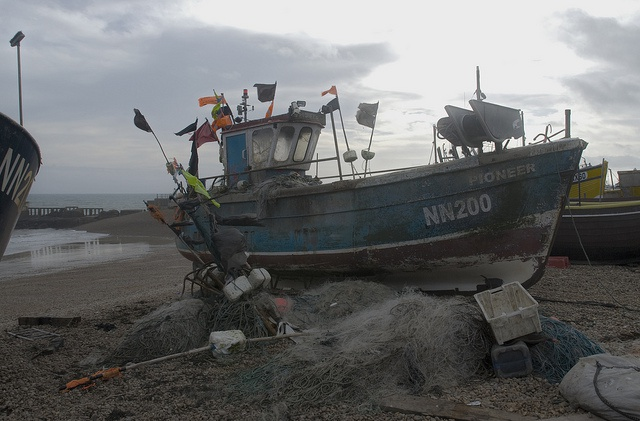Describe the objects in this image and their specific colors. I can see boat in darkgray, black, gray, and darkblue tones, boat in darkgray, black, gray, and darkgreen tones, boat in darkgray, black, and gray tones, and boat in darkgray, darkgreen, black, and gray tones in this image. 